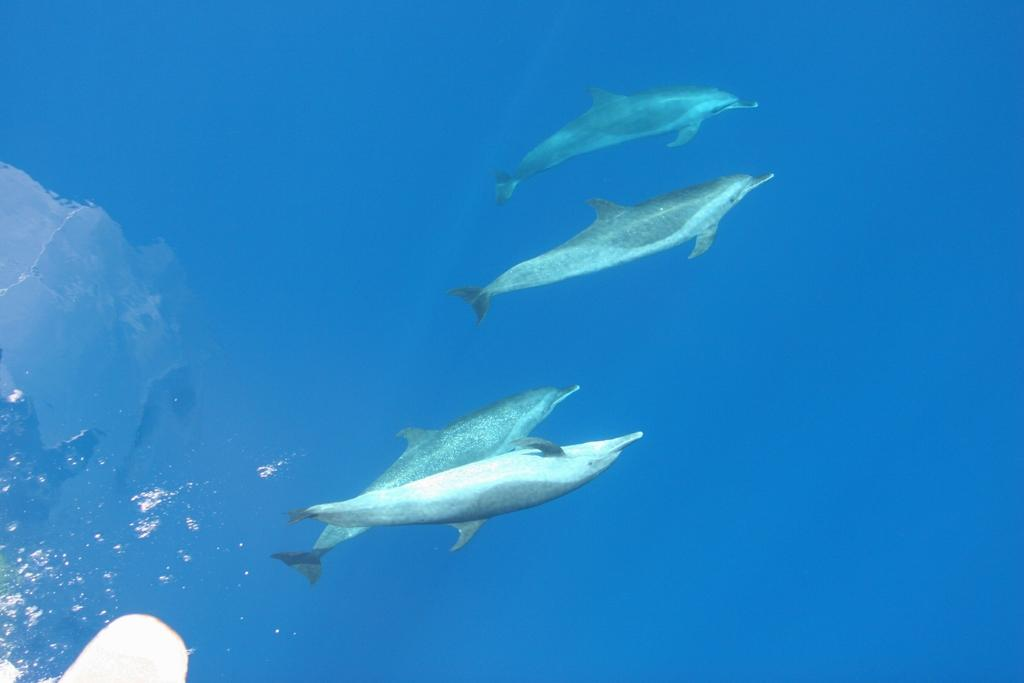How many fishes can be seen in the image? There are four fishes in the image. Where are the fishes located? The fishes are in the water. What type of metal is being used in the battle depicted in the image? There is no battle or metal present in the image; it features four fishes in the water. What act are the fishes performing in the image? The fishes are not performing any specific act in the image; they are simply swimming in the water. 